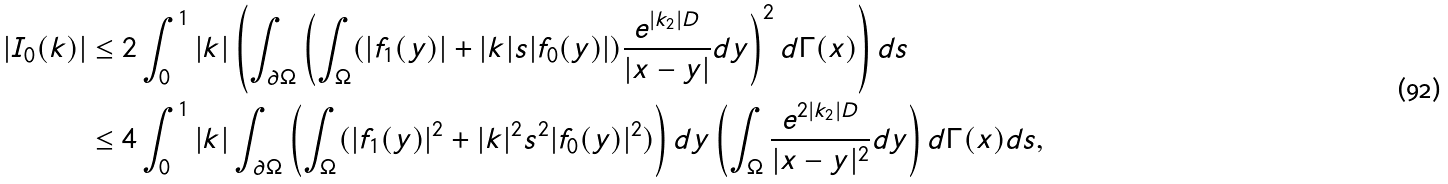<formula> <loc_0><loc_0><loc_500><loc_500>| I _ { 0 } ( k ) | & \leq 2 \int _ { 0 } ^ { 1 } | k | \left ( \int _ { \partial \Omega } \left ( \int _ { \Omega } ( | f _ { 1 } ( y ) | + | k | s | f _ { 0 } ( y ) | ) \frac { e ^ { | k _ { 2 } | D } } { | x - y | } d y \right ) ^ { 2 } d \Gamma ( x ) \right ) d s \\ & \leq 4 \int _ { 0 } ^ { 1 } | k | \int _ { \partial \Omega } \left ( \int _ { \Omega } ( | f _ { 1 } ( y ) | ^ { 2 } + | k | ^ { 2 } s ^ { 2 } | f _ { 0 } ( y ) | ^ { 2 } ) \right ) d y \left ( \int _ { \Omega } \frac { e ^ { 2 | k _ { 2 } | D } } { | x - y | ^ { 2 } } d y \right ) d \Gamma ( x ) d s ,</formula> 